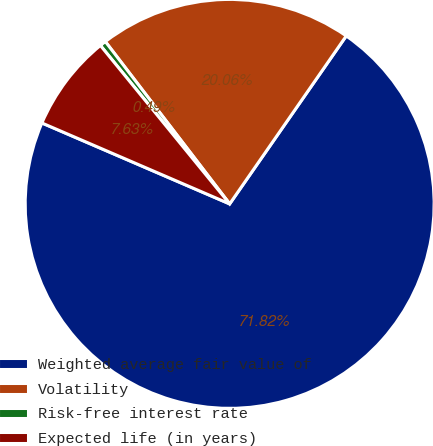Convert chart. <chart><loc_0><loc_0><loc_500><loc_500><pie_chart><fcel>Weighted average fair value of<fcel>Volatility<fcel>Risk-free interest rate<fcel>Expected life (in years)<nl><fcel>71.82%<fcel>20.06%<fcel>0.49%<fcel>7.63%<nl></chart> 